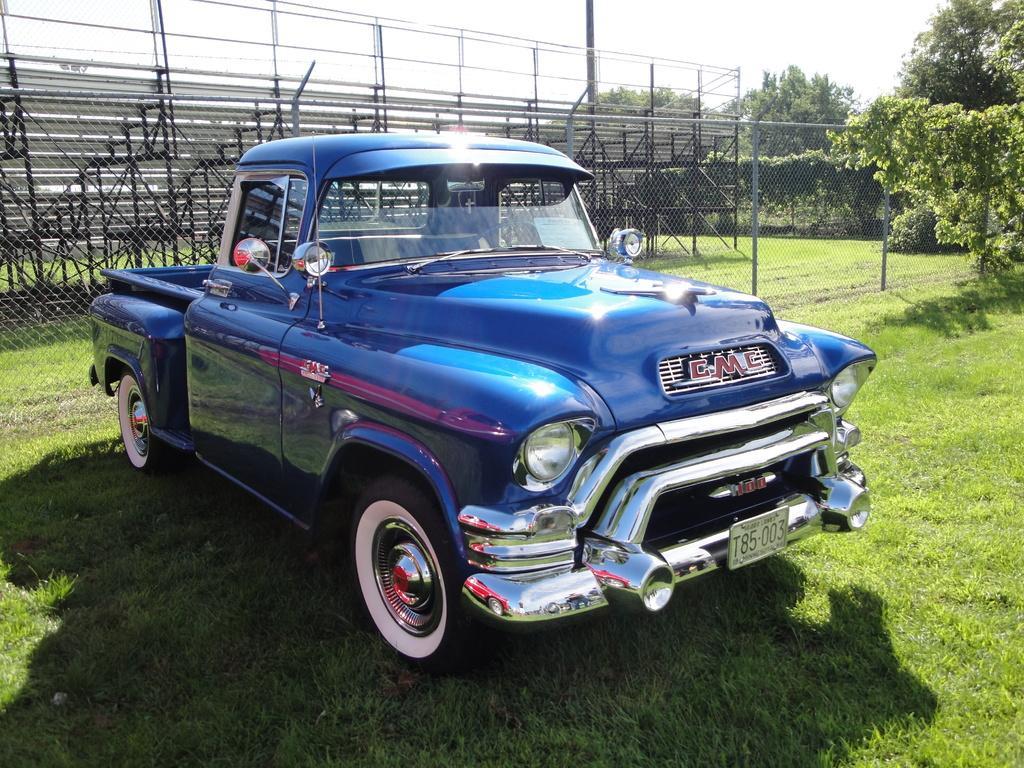Please provide a concise description of this image. In this image we can see a car parked on the surface of the grass, behind the car there are some fencing with metal rods. In the background of the image there are trees and sky. 